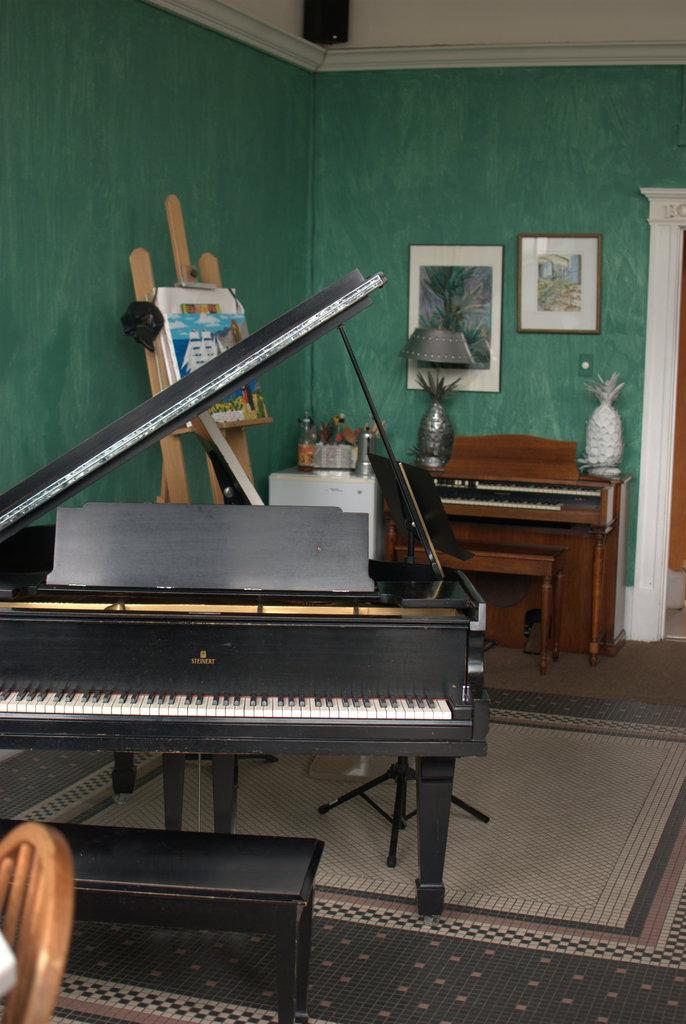What object in the image is used for creating music? There is a musical instrument in the image that is used for creating music. Where is the musical instrument located in the image? The musical instrument is in the middle of the image. What type of lighting is present in the image? There is a lamp in the image. What type of decorative element can be seen in the image? There are photos behind a wall in the image. What type of test can be seen being conducted in the image? There is no test present in the image; it features a musical instrument, a lamp, and photos behind a wall. What type of mine is visible in the image? There is no mine present in the image; it features a musical instrument, a lamp, and photos behind a wall. 